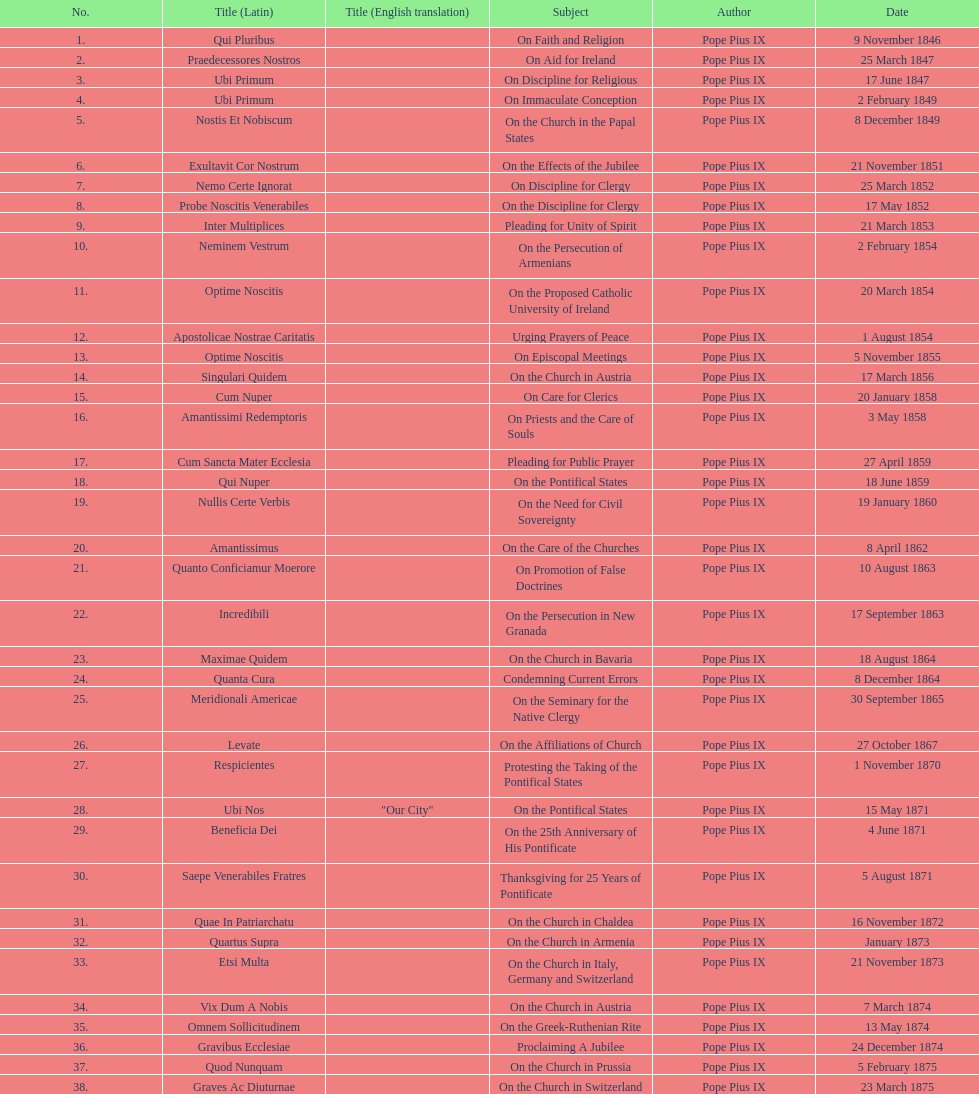Total number of encyclicals on churches . 11. 